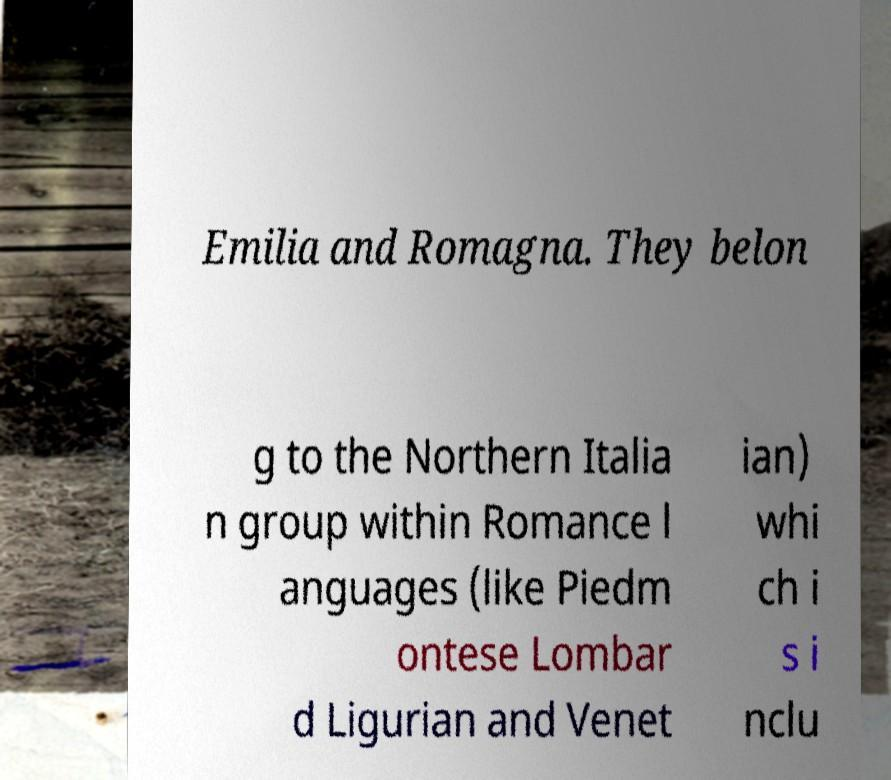I need the written content from this picture converted into text. Can you do that? Emilia and Romagna. They belon g to the Northern Italia n group within Romance l anguages (like Piedm ontese Lombar d Ligurian and Venet ian) whi ch i s i nclu 